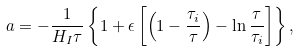Convert formula to latex. <formula><loc_0><loc_0><loc_500><loc_500>a = - \frac { 1 } { H _ { I } \tau } \left \{ 1 + \epsilon \left [ \left ( 1 - \frac { \tau _ { i } } { \tau } \right ) - \ln \frac { \tau } { \tau _ { i } } \right ] \right \} ,</formula> 